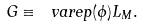Convert formula to latex. <formula><loc_0><loc_0><loc_500><loc_500>G \equiv \ v a r e p ( \phi ) L _ { M } .</formula> 